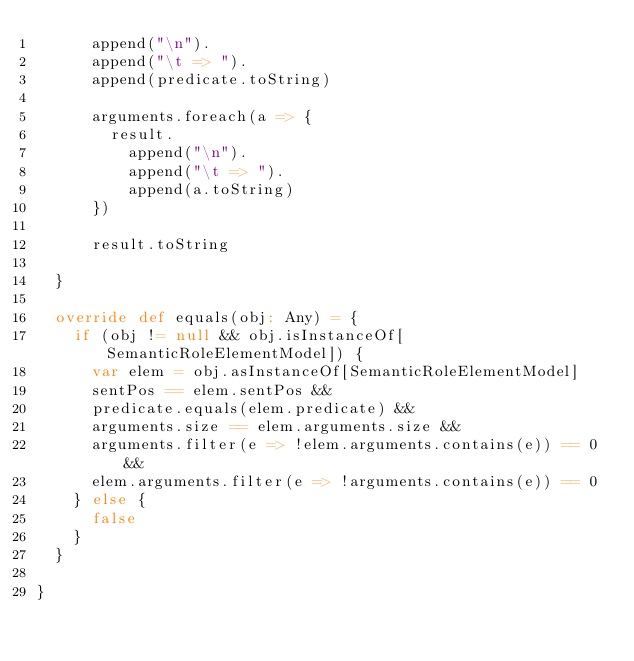Convert code to text. <code><loc_0><loc_0><loc_500><loc_500><_Scala_>      append("\n").
      append("\t => ").
      append(predicate.toString)

      arguments.foreach(a => {
        result.
          append("\n").
          append("\t => ").
          append(a.toString)
      })

      result.toString

  }

  override def equals(obj: Any) = {
    if (obj != null && obj.isInstanceOf[SemanticRoleElementModel]) {
      var elem = obj.asInstanceOf[SemanticRoleElementModel]
      sentPos == elem.sentPos &&
      predicate.equals(elem.predicate) &&
      arguments.size == elem.arguments.size &&
      arguments.filter(e => !elem.arguments.contains(e)) == 0 &&
      elem.arguments.filter(e => !arguments.contains(e)) == 0
    } else {
      false
    }
  }

}</code> 